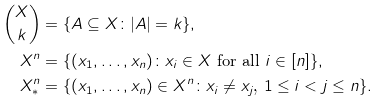Convert formula to latex. <formula><loc_0><loc_0><loc_500><loc_500>\binom { X } { k } & = \{ A \subseteq X \colon | A | = k \} , \\ X ^ { n } & = \{ ( x _ { 1 } , \dots , x _ { n } ) \colon \text {$x_{i}\in X$ for all $i\in[n]$} \} , \\ X ^ { n } _ { * } & = \{ ( x _ { 1 } , \dots , x _ { n } ) \in X ^ { n } \colon \text {$x_{i}\not= x_{j}$, $1\leq i<j\leq n$} \} .</formula> 